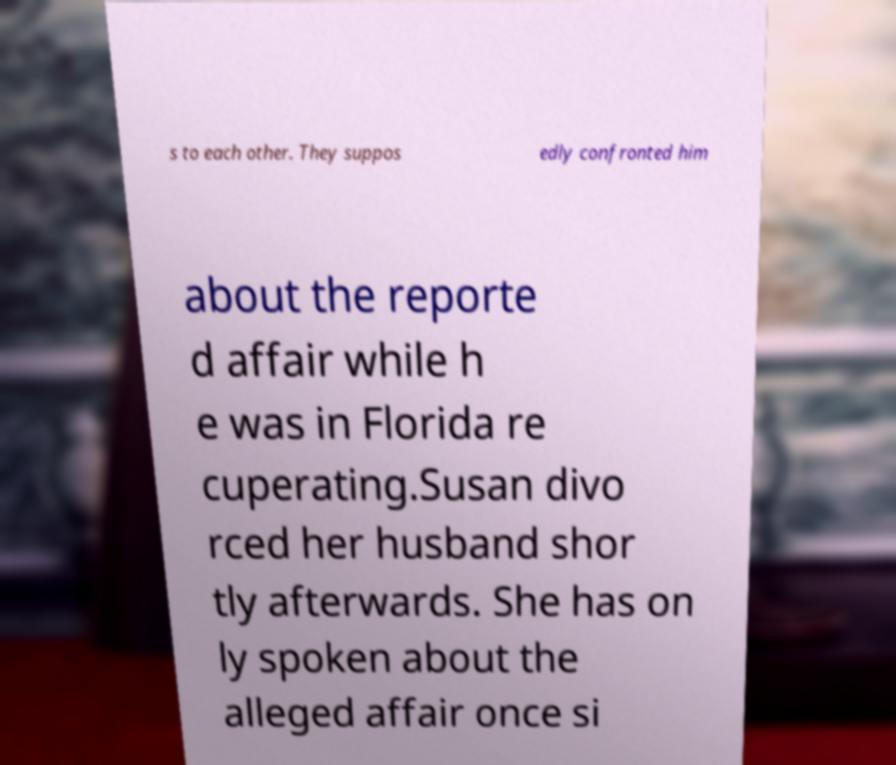Can you accurately transcribe the text from the provided image for me? s to each other. They suppos edly confronted him about the reporte d affair while h e was in Florida re cuperating.Susan divo rced her husband shor tly afterwards. She has on ly spoken about the alleged affair once si 